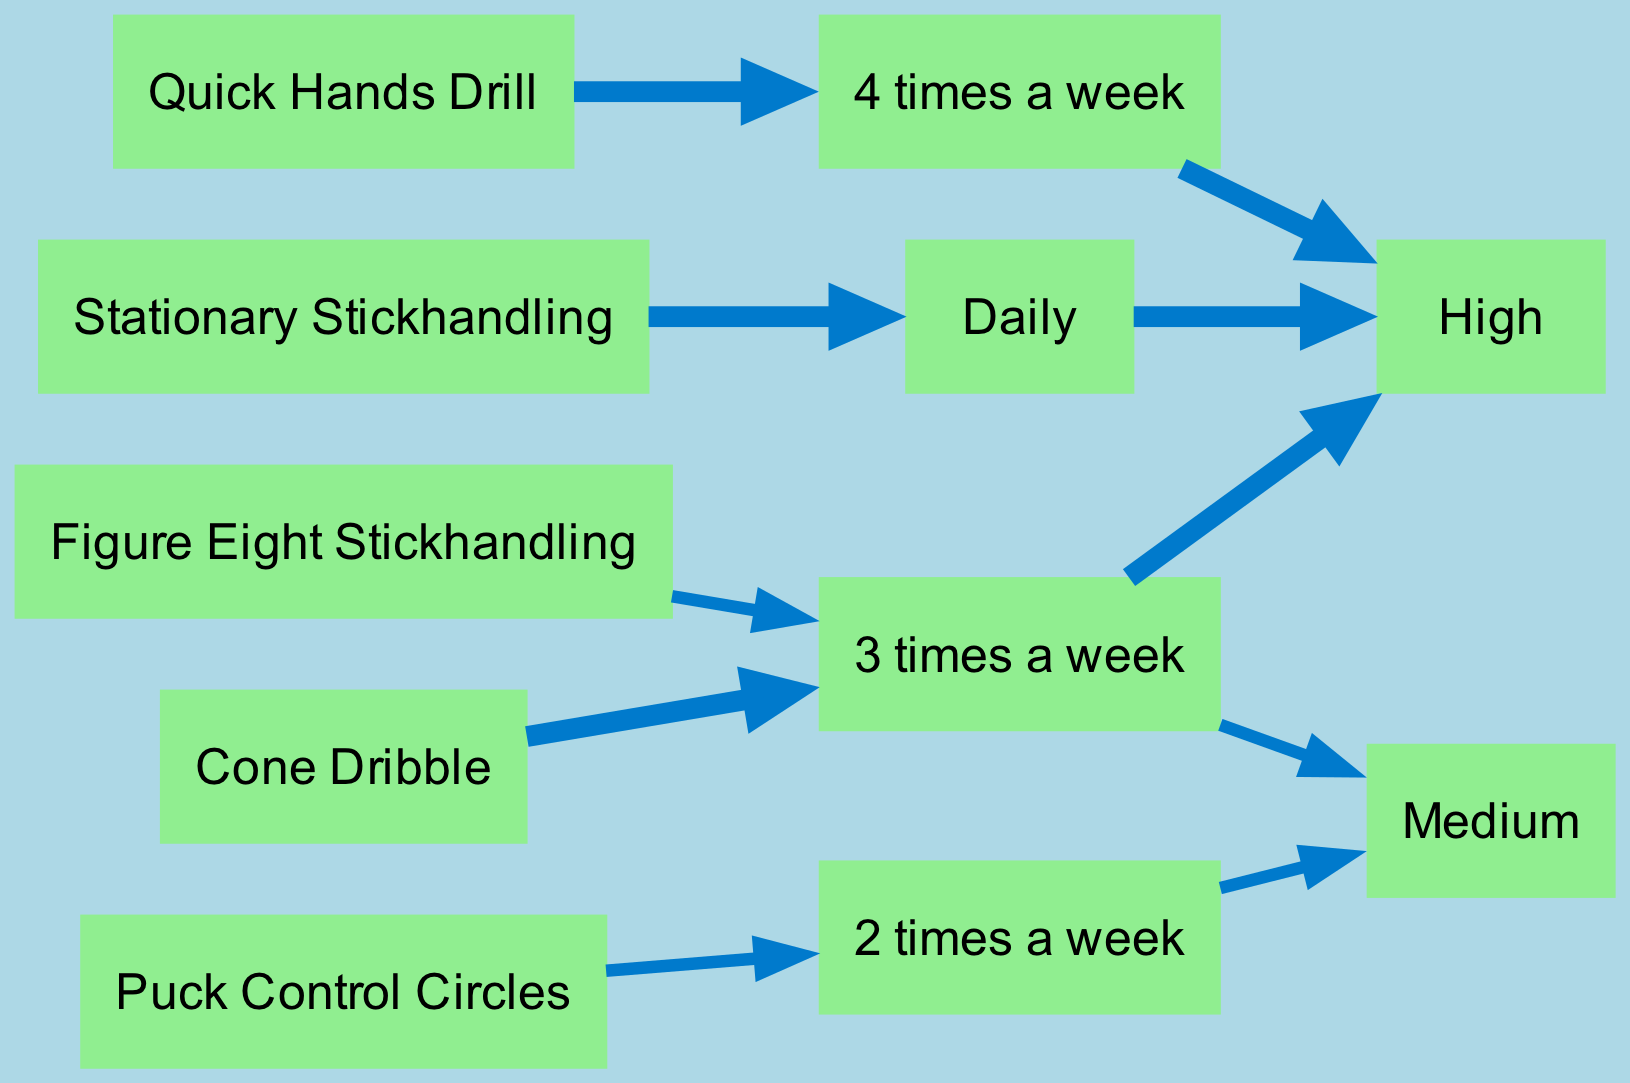What is the most frequently recommended drill for stickhandling? The diagram shows the different drills along with their frequencies. Identifying the drill with the highest frequency, the "Quick Hands Drill" is practiced 4 times a week.
Answer: Quick Hands Drill Which drill has a medium effectiveness rating? By examining the effectiveness nodes in the diagram, the drills that connect to the "Medium" node are "Puck Control Circles" and "Figure Eight Stickhandling." The answer can be either of the two drills.
Answer: Puck Control Circles or Figure Eight Stickhandling How many drills recommended practicing daily? The diagram shows the frequency of each drill. Only one drill, "Stationary Stickhandling," is mentioned under the "Daily" frequency.
Answer: 1 What is the effectiveness of the "Cone Dribble" drill? Following the edges from the "Cone Dribble" node, it leads to the "3 times a week" frequency and then to the "High" effectiveness node. Thus, the effectiveness for this drill is "High."
Answer: High Which drill is the least frequently practiced according to the diagram? Comparing the frequency of all drills, the "Puck Control Circles" at "2 times a week" is the lowest frequency practice among the listed drills.
Answer: Puck Control Circles Is there a drill with both high frequency and effectiveness? The diagram demonstrates that "Quick Hands Drill" has a frequency of "4 times a week" and an effectiveness rating of "High," confirming that there is indeed a drill meeting both criteria.
Answer: Yes What is the connection weight for the "Stationary Stickhandling" drill? The weight of the edges is determined by the effectiveness. Since "Stationary Stickhandling" has a "High" effectiveness rating, the connection weight to both frequency and effectiveness would be 5.
Answer: 5 Which frequency is shared by the "Cone Dribble" and the "Figure Eight Stickhandling" drills? The diagram states that both drills connect to the "3 times a week" frequency. This indicates they share the same frequency of practice.
Answer: 3 times a week 